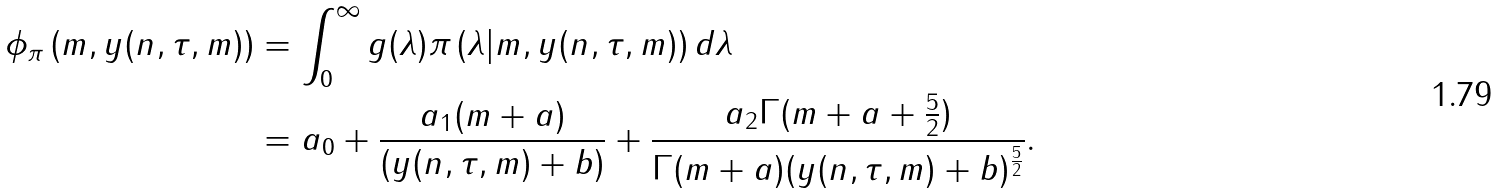Convert formula to latex. <formula><loc_0><loc_0><loc_500><loc_500>\phi _ { \pi } \left ( m , y ( n , \tau , m ) \right ) & = \int _ { 0 } ^ { \infty } g ( \lambda ) \pi \left ( \lambda | m , y ( n , \tau , m ) \right ) d \lambda \\ & = a _ { 0 } + \frac { a _ { 1 } ( m + a ) } { ( y ( n , \tau , m ) + b ) } + \frac { a _ { 2 } \Gamma ( m + a + \frac { 5 } { 2 } ) } { \Gamma ( m + a ) ( y ( n , \tau , m ) + b ) ^ { \frac { 5 } { 2 } } } .</formula> 